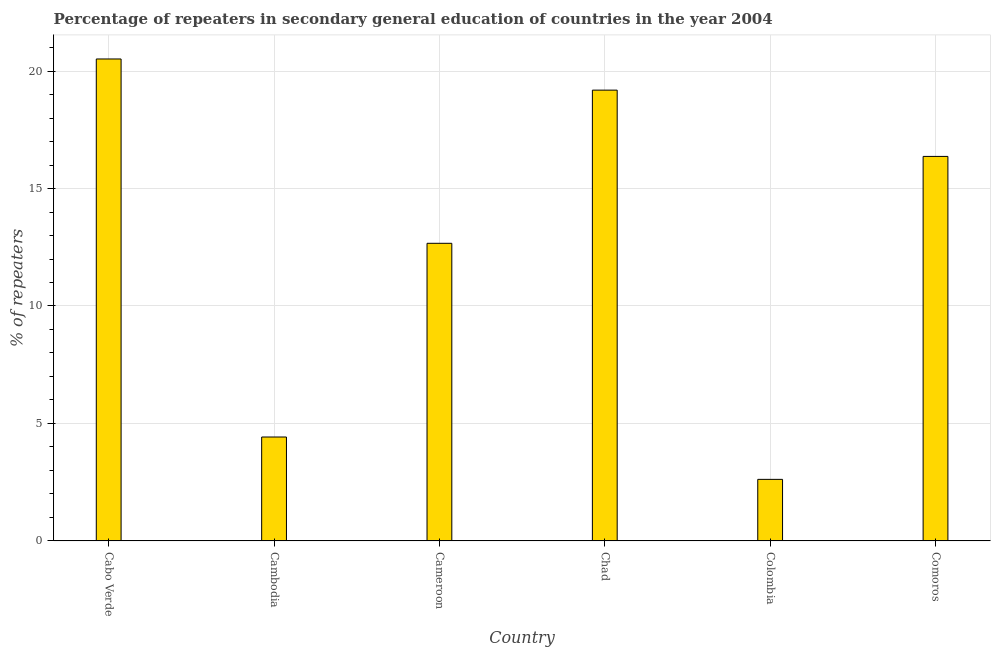What is the title of the graph?
Ensure brevity in your answer.  Percentage of repeaters in secondary general education of countries in the year 2004. What is the label or title of the X-axis?
Your answer should be compact. Country. What is the label or title of the Y-axis?
Provide a short and direct response. % of repeaters. What is the percentage of repeaters in Chad?
Your response must be concise. 19.19. Across all countries, what is the maximum percentage of repeaters?
Give a very brief answer. 20.51. Across all countries, what is the minimum percentage of repeaters?
Your response must be concise. 2.62. In which country was the percentage of repeaters maximum?
Your answer should be very brief. Cabo Verde. In which country was the percentage of repeaters minimum?
Offer a very short reply. Colombia. What is the sum of the percentage of repeaters?
Offer a terse response. 75.78. What is the difference between the percentage of repeaters in Cabo Verde and Chad?
Provide a succinct answer. 1.33. What is the average percentage of repeaters per country?
Offer a very short reply. 12.63. What is the median percentage of repeaters?
Provide a succinct answer. 14.52. In how many countries, is the percentage of repeaters greater than 4 %?
Your answer should be compact. 5. What is the ratio of the percentage of repeaters in Cabo Verde to that in Chad?
Give a very brief answer. 1.07. Is the difference between the percentage of repeaters in Cameroon and Chad greater than the difference between any two countries?
Offer a very short reply. No. What is the difference between the highest and the second highest percentage of repeaters?
Your answer should be compact. 1.33. What is the difference between the highest and the lowest percentage of repeaters?
Your answer should be very brief. 17.89. In how many countries, is the percentage of repeaters greater than the average percentage of repeaters taken over all countries?
Your answer should be very brief. 4. Are all the bars in the graph horizontal?
Provide a succinct answer. No. How many countries are there in the graph?
Offer a terse response. 6. What is the difference between two consecutive major ticks on the Y-axis?
Give a very brief answer. 5. What is the % of repeaters in Cabo Verde?
Give a very brief answer. 20.51. What is the % of repeaters in Cambodia?
Ensure brevity in your answer.  4.42. What is the % of repeaters of Cameroon?
Offer a terse response. 12.67. What is the % of repeaters in Chad?
Offer a terse response. 19.19. What is the % of repeaters of Colombia?
Make the answer very short. 2.62. What is the % of repeaters of Comoros?
Offer a very short reply. 16.37. What is the difference between the % of repeaters in Cabo Verde and Cambodia?
Your response must be concise. 16.09. What is the difference between the % of repeaters in Cabo Verde and Cameroon?
Your answer should be very brief. 7.85. What is the difference between the % of repeaters in Cabo Verde and Chad?
Your answer should be compact. 1.33. What is the difference between the % of repeaters in Cabo Verde and Colombia?
Give a very brief answer. 17.89. What is the difference between the % of repeaters in Cabo Verde and Comoros?
Ensure brevity in your answer.  4.15. What is the difference between the % of repeaters in Cambodia and Cameroon?
Your answer should be compact. -8.25. What is the difference between the % of repeaters in Cambodia and Chad?
Your answer should be very brief. -14.76. What is the difference between the % of repeaters in Cambodia and Colombia?
Your response must be concise. 1.8. What is the difference between the % of repeaters in Cambodia and Comoros?
Provide a short and direct response. -11.94. What is the difference between the % of repeaters in Cameroon and Chad?
Provide a short and direct response. -6.52. What is the difference between the % of repeaters in Cameroon and Colombia?
Provide a succinct answer. 10.05. What is the difference between the % of repeaters in Cameroon and Comoros?
Provide a succinct answer. -3.7. What is the difference between the % of repeaters in Chad and Colombia?
Provide a succinct answer. 16.57. What is the difference between the % of repeaters in Chad and Comoros?
Keep it short and to the point. 2.82. What is the difference between the % of repeaters in Colombia and Comoros?
Make the answer very short. -13.75. What is the ratio of the % of repeaters in Cabo Verde to that in Cambodia?
Ensure brevity in your answer.  4.64. What is the ratio of the % of repeaters in Cabo Verde to that in Cameroon?
Your response must be concise. 1.62. What is the ratio of the % of repeaters in Cabo Verde to that in Chad?
Your answer should be compact. 1.07. What is the ratio of the % of repeaters in Cabo Verde to that in Colombia?
Offer a very short reply. 7.83. What is the ratio of the % of repeaters in Cabo Verde to that in Comoros?
Keep it short and to the point. 1.25. What is the ratio of the % of repeaters in Cambodia to that in Cameroon?
Your answer should be very brief. 0.35. What is the ratio of the % of repeaters in Cambodia to that in Chad?
Offer a terse response. 0.23. What is the ratio of the % of repeaters in Cambodia to that in Colombia?
Ensure brevity in your answer.  1.69. What is the ratio of the % of repeaters in Cambodia to that in Comoros?
Provide a succinct answer. 0.27. What is the ratio of the % of repeaters in Cameroon to that in Chad?
Give a very brief answer. 0.66. What is the ratio of the % of repeaters in Cameroon to that in Colombia?
Your answer should be compact. 4.83. What is the ratio of the % of repeaters in Cameroon to that in Comoros?
Give a very brief answer. 0.77. What is the ratio of the % of repeaters in Chad to that in Colombia?
Provide a succinct answer. 7.32. What is the ratio of the % of repeaters in Chad to that in Comoros?
Make the answer very short. 1.17. What is the ratio of the % of repeaters in Colombia to that in Comoros?
Ensure brevity in your answer.  0.16. 